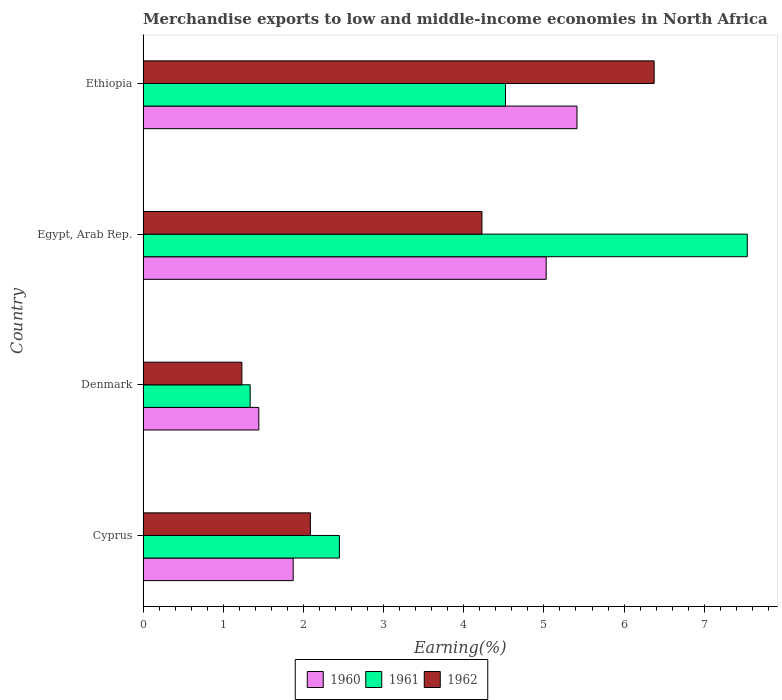Are the number of bars on each tick of the Y-axis equal?
Your response must be concise. Yes. What is the label of the 1st group of bars from the top?
Provide a succinct answer. Ethiopia. In how many cases, is the number of bars for a given country not equal to the number of legend labels?
Offer a very short reply. 0. What is the percentage of amount earned from merchandise exports in 1961 in Egypt, Arab Rep.?
Ensure brevity in your answer.  7.54. Across all countries, what is the maximum percentage of amount earned from merchandise exports in 1961?
Offer a very short reply. 7.54. Across all countries, what is the minimum percentage of amount earned from merchandise exports in 1962?
Your answer should be compact. 1.23. In which country was the percentage of amount earned from merchandise exports in 1960 maximum?
Your response must be concise. Ethiopia. In which country was the percentage of amount earned from merchandise exports in 1961 minimum?
Give a very brief answer. Denmark. What is the total percentage of amount earned from merchandise exports in 1962 in the graph?
Your response must be concise. 13.92. What is the difference between the percentage of amount earned from merchandise exports in 1961 in Cyprus and that in Ethiopia?
Ensure brevity in your answer.  -2.07. What is the difference between the percentage of amount earned from merchandise exports in 1960 in Ethiopia and the percentage of amount earned from merchandise exports in 1961 in Egypt, Arab Rep.?
Offer a terse response. -2.12. What is the average percentage of amount earned from merchandise exports in 1961 per country?
Make the answer very short. 3.96. What is the difference between the percentage of amount earned from merchandise exports in 1961 and percentage of amount earned from merchandise exports in 1960 in Ethiopia?
Ensure brevity in your answer.  -0.89. In how many countries, is the percentage of amount earned from merchandise exports in 1960 greater than 1 %?
Give a very brief answer. 4. What is the ratio of the percentage of amount earned from merchandise exports in 1960 in Egypt, Arab Rep. to that in Ethiopia?
Provide a short and direct response. 0.93. What is the difference between the highest and the second highest percentage of amount earned from merchandise exports in 1960?
Offer a very short reply. 0.38. What is the difference between the highest and the lowest percentage of amount earned from merchandise exports in 1960?
Give a very brief answer. 3.97. In how many countries, is the percentage of amount earned from merchandise exports in 1960 greater than the average percentage of amount earned from merchandise exports in 1960 taken over all countries?
Offer a terse response. 2. Is the sum of the percentage of amount earned from merchandise exports in 1960 in Denmark and Ethiopia greater than the maximum percentage of amount earned from merchandise exports in 1961 across all countries?
Your answer should be very brief. No. What does the 2nd bar from the top in Denmark represents?
Offer a terse response. 1961. Is it the case that in every country, the sum of the percentage of amount earned from merchandise exports in 1960 and percentage of amount earned from merchandise exports in 1962 is greater than the percentage of amount earned from merchandise exports in 1961?
Provide a succinct answer. Yes. How many bars are there?
Your answer should be very brief. 12. Are all the bars in the graph horizontal?
Your response must be concise. Yes. How many countries are there in the graph?
Offer a very short reply. 4. What is the difference between two consecutive major ticks on the X-axis?
Make the answer very short. 1. Does the graph contain any zero values?
Provide a short and direct response. No. Does the graph contain grids?
Your answer should be compact. No. Where does the legend appear in the graph?
Give a very brief answer. Bottom center. How are the legend labels stacked?
Keep it short and to the point. Horizontal. What is the title of the graph?
Keep it short and to the point. Merchandise exports to low and middle-income economies in North Africa. What is the label or title of the X-axis?
Your answer should be compact. Earning(%). What is the label or title of the Y-axis?
Provide a succinct answer. Country. What is the Earning(%) of 1960 in Cyprus?
Your answer should be compact. 1.87. What is the Earning(%) of 1961 in Cyprus?
Offer a terse response. 2.45. What is the Earning(%) in 1962 in Cyprus?
Make the answer very short. 2.09. What is the Earning(%) of 1960 in Denmark?
Your response must be concise. 1.44. What is the Earning(%) in 1961 in Denmark?
Offer a terse response. 1.34. What is the Earning(%) in 1962 in Denmark?
Provide a succinct answer. 1.23. What is the Earning(%) in 1960 in Egypt, Arab Rep.?
Your answer should be compact. 5.03. What is the Earning(%) of 1961 in Egypt, Arab Rep.?
Your answer should be very brief. 7.54. What is the Earning(%) of 1962 in Egypt, Arab Rep.?
Give a very brief answer. 4.23. What is the Earning(%) in 1960 in Ethiopia?
Ensure brevity in your answer.  5.41. What is the Earning(%) of 1961 in Ethiopia?
Ensure brevity in your answer.  4.52. What is the Earning(%) of 1962 in Ethiopia?
Offer a terse response. 6.38. Across all countries, what is the maximum Earning(%) in 1960?
Your answer should be compact. 5.41. Across all countries, what is the maximum Earning(%) of 1961?
Your response must be concise. 7.54. Across all countries, what is the maximum Earning(%) of 1962?
Ensure brevity in your answer.  6.38. Across all countries, what is the minimum Earning(%) in 1960?
Provide a short and direct response. 1.44. Across all countries, what is the minimum Earning(%) of 1961?
Provide a short and direct response. 1.34. Across all countries, what is the minimum Earning(%) in 1962?
Offer a terse response. 1.23. What is the total Earning(%) of 1960 in the graph?
Provide a short and direct response. 13.76. What is the total Earning(%) in 1961 in the graph?
Your response must be concise. 15.84. What is the total Earning(%) of 1962 in the graph?
Offer a very short reply. 13.92. What is the difference between the Earning(%) of 1960 in Cyprus and that in Denmark?
Your response must be concise. 0.43. What is the difference between the Earning(%) of 1961 in Cyprus and that in Denmark?
Offer a very short reply. 1.11. What is the difference between the Earning(%) in 1962 in Cyprus and that in Denmark?
Give a very brief answer. 0.85. What is the difference between the Earning(%) in 1960 in Cyprus and that in Egypt, Arab Rep.?
Provide a short and direct response. -3.16. What is the difference between the Earning(%) of 1961 in Cyprus and that in Egypt, Arab Rep.?
Keep it short and to the point. -5.09. What is the difference between the Earning(%) of 1962 in Cyprus and that in Egypt, Arab Rep.?
Make the answer very short. -2.14. What is the difference between the Earning(%) in 1960 in Cyprus and that in Ethiopia?
Keep it short and to the point. -3.54. What is the difference between the Earning(%) in 1961 in Cyprus and that in Ethiopia?
Offer a very short reply. -2.07. What is the difference between the Earning(%) of 1962 in Cyprus and that in Ethiopia?
Keep it short and to the point. -4.29. What is the difference between the Earning(%) of 1960 in Denmark and that in Egypt, Arab Rep.?
Keep it short and to the point. -3.58. What is the difference between the Earning(%) in 1961 in Denmark and that in Egypt, Arab Rep.?
Your answer should be very brief. -6.2. What is the difference between the Earning(%) of 1962 in Denmark and that in Egypt, Arab Rep.?
Offer a very short reply. -2.99. What is the difference between the Earning(%) in 1960 in Denmark and that in Ethiopia?
Give a very brief answer. -3.97. What is the difference between the Earning(%) of 1961 in Denmark and that in Ethiopia?
Your answer should be very brief. -3.19. What is the difference between the Earning(%) in 1962 in Denmark and that in Ethiopia?
Your answer should be very brief. -5.14. What is the difference between the Earning(%) in 1960 in Egypt, Arab Rep. and that in Ethiopia?
Your response must be concise. -0.38. What is the difference between the Earning(%) of 1961 in Egypt, Arab Rep. and that in Ethiopia?
Offer a very short reply. 3.02. What is the difference between the Earning(%) of 1962 in Egypt, Arab Rep. and that in Ethiopia?
Offer a very short reply. -2.15. What is the difference between the Earning(%) in 1960 in Cyprus and the Earning(%) in 1961 in Denmark?
Offer a terse response. 0.54. What is the difference between the Earning(%) in 1960 in Cyprus and the Earning(%) in 1962 in Denmark?
Give a very brief answer. 0.64. What is the difference between the Earning(%) in 1961 in Cyprus and the Earning(%) in 1962 in Denmark?
Provide a succinct answer. 1.22. What is the difference between the Earning(%) in 1960 in Cyprus and the Earning(%) in 1961 in Egypt, Arab Rep.?
Keep it short and to the point. -5.66. What is the difference between the Earning(%) in 1960 in Cyprus and the Earning(%) in 1962 in Egypt, Arab Rep.?
Ensure brevity in your answer.  -2.35. What is the difference between the Earning(%) of 1961 in Cyprus and the Earning(%) of 1962 in Egypt, Arab Rep.?
Ensure brevity in your answer.  -1.78. What is the difference between the Earning(%) of 1960 in Cyprus and the Earning(%) of 1961 in Ethiopia?
Give a very brief answer. -2.65. What is the difference between the Earning(%) in 1960 in Cyprus and the Earning(%) in 1962 in Ethiopia?
Offer a very short reply. -4.5. What is the difference between the Earning(%) of 1961 in Cyprus and the Earning(%) of 1962 in Ethiopia?
Your answer should be compact. -3.93. What is the difference between the Earning(%) of 1960 in Denmark and the Earning(%) of 1961 in Egypt, Arab Rep.?
Your answer should be very brief. -6.09. What is the difference between the Earning(%) in 1960 in Denmark and the Earning(%) in 1962 in Egypt, Arab Rep.?
Make the answer very short. -2.78. What is the difference between the Earning(%) of 1961 in Denmark and the Earning(%) of 1962 in Egypt, Arab Rep.?
Provide a short and direct response. -2.89. What is the difference between the Earning(%) of 1960 in Denmark and the Earning(%) of 1961 in Ethiopia?
Give a very brief answer. -3.08. What is the difference between the Earning(%) in 1960 in Denmark and the Earning(%) in 1962 in Ethiopia?
Offer a very short reply. -4.93. What is the difference between the Earning(%) in 1961 in Denmark and the Earning(%) in 1962 in Ethiopia?
Provide a succinct answer. -5.04. What is the difference between the Earning(%) in 1960 in Egypt, Arab Rep. and the Earning(%) in 1961 in Ethiopia?
Ensure brevity in your answer.  0.51. What is the difference between the Earning(%) of 1960 in Egypt, Arab Rep. and the Earning(%) of 1962 in Ethiopia?
Make the answer very short. -1.35. What is the difference between the Earning(%) of 1961 in Egypt, Arab Rep. and the Earning(%) of 1962 in Ethiopia?
Provide a succinct answer. 1.16. What is the average Earning(%) of 1960 per country?
Your response must be concise. 3.44. What is the average Earning(%) in 1961 per country?
Make the answer very short. 3.96. What is the average Earning(%) of 1962 per country?
Give a very brief answer. 3.48. What is the difference between the Earning(%) of 1960 and Earning(%) of 1961 in Cyprus?
Provide a succinct answer. -0.58. What is the difference between the Earning(%) of 1960 and Earning(%) of 1962 in Cyprus?
Provide a succinct answer. -0.21. What is the difference between the Earning(%) in 1961 and Earning(%) in 1962 in Cyprus?
Provide a succinct answer. 0.36. What is the difference between the Earning(%) of 1960 and Earning(%) of 1961 in Denmark?
Give a very brief answer. 0.11. What is the difference between the Earning(%) of 1960 and Earning(%) of 1962 in Denmark?
Give a very brief answer. 0.21. What is the difference between the Earning(%) of 1961 and Earning(%) of 1962 in Denmark?
Keep it short and to the point. 0.1. What is the difference between the Earning(%) of 1960 and Earning(%) of 1961 in Egypt, Arab Rep.?
Provide a short and direct response. -2.51. What is the difference between the Earning(%) of 1960 and Earning(%) of 1962 in Egypt, Arab Rep.?
Your answer should be compact. 0.8. What is the difference between the Earning(%) in 1961 and Earning(%) in 1962 in Egypt, Arab Rep.?
Provide a short and direct response. 3.31. What is the difference between the Earning(%) of 1960 and Earning(%) of 1961 in Ethiopia?
Give a very brief answer. 0.89. What is the difference between the Earning(%) of 1960 and Earning(%) of 1962 in Ethiopia?
Your response must be concise. -0.96. What is the difference between the Earning(%) in 1961 and Earning(%) in 1962 in Ethiopia?
Ensure brevity in your answer.  -1.85. What is the ratio of the Earning(%) in 1960 in Cyprus to that in Denmark?
Offer a terse response. 1.3. What is the ratio of the Earning(%) of 1961 in Cyprus to that in Denmark?
Your answer should be very brief. 1.83. What is the ratio of the Earning(%) in 1962 in Cyprus to that in Denmark?
Make the answer very short. 1.69. What is the ratio of the Earning(%) in 1960 in Cyprus to that in Egypt, Arab Rep.?
Offer a terse response. 0.37. What is the ratio of the Earning(%) of 1961 in Cyprus to that in Egypt, Arab Rep.?
Provide a succinct answer. 0.32. What is the ratio of the Earning(%) in 1962 in Cyprus to that in Egypt, Arab Rep.?
Offer a very short reply. 0.49. What is the ratio of the Earning(%) in 1960 in Cyprus to that in Ethiopia?
Ensure brevity in your answer.  0.35. What is the ratio of the Earning(%) in 1961 in Cyprus to that in Ethiopia?
Your answer should be compact. 0.54. What is the ratio of the Earning(%) in 1962 in Cyprus to that in Ethiopia?
Offer a terse response. 0.33. What is the ratio of the Earning(%) in 1960 in Denmark to that in Egypt, Arab Rep.?
Offer a very short reply. 0.29. What is the ratio of the Earning(%) in 1961 in Denmark to that in Egypt, Arab Rep.?
Offer a terse response. 0.18. What is the ratio of the Earning(%) of 1962 in Denmark to that in Egypt, Arab Rep.?
Keep it short and to the point. 0.29. What is the ratio of the Earning(%) of 1960 in Denmark to that in Ethiopia?
Offer a very short reply. 0.27. What is the ratio of the Earning(%) of 1961 in Denmark to that in Ethiopia?
Make the answer very short. 0.3. What is the ratio of the Earning(%) in 1962 in Denmark to that in Ethiopia?
Keep it short and to the point. 0.19. What is the ratio of the Earning(%) in 1960 in Egypt, Arab Rep. to that in Ethiopia?
Your answer should be very brief. 0.93. What is the ratio of the Earning(%) of 1961 in Egypt, Arab Rep. to that in Ethiopia?
Your answer should be compact. 1.67. What is the ratio of the Earning(%) in 1962 in Egypt, Arab Rep. to that in Ethiopia?
Keep it short and to the point. 0.66. What is the difference between the highest and the second highest Earning(%) in 1960?
Provide a short and direct response. 0.38. What is the difference between the highest and the second highest Earning(%) of 1961?
Provide a succinct answer. 3.02. What is the difference between the highest and the second highest Earning(%) of 1962?
Provide a short and direct response. 2.15. What is the difference between the highest and the lowest Earning(%) of 1960?
Provide a succinct answer. 3.97. What is the difference between the highest and the lowest Earning(%) of 1961?
Provide a short and direct response. 6.2. What is the difference between the highest and the lowest Earning(%) in 1962?
Offer a very short reply. 5.14. 